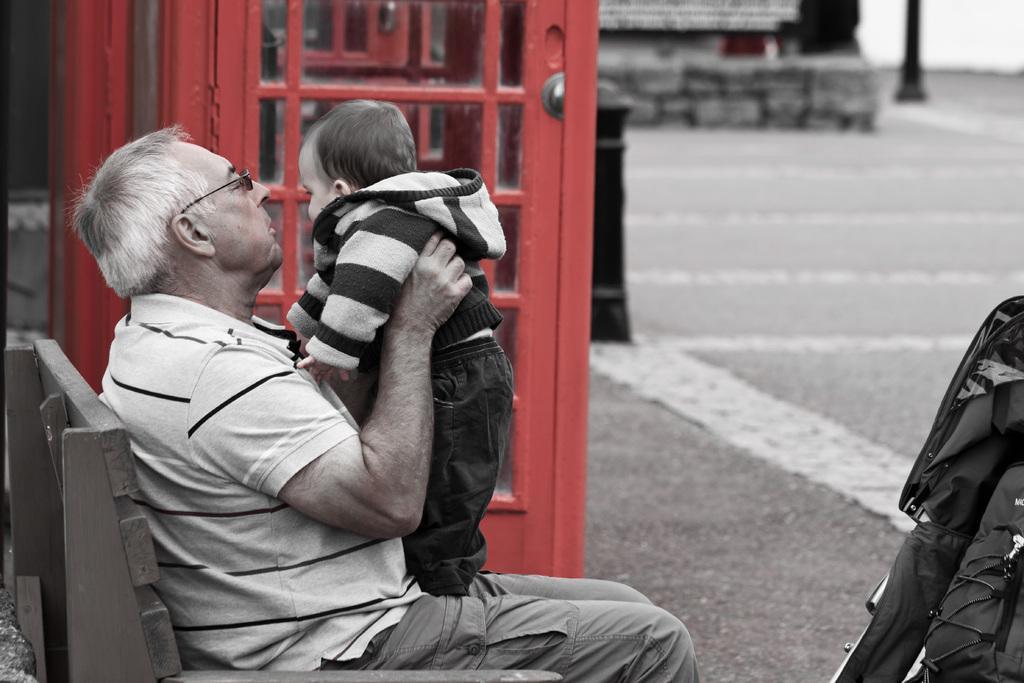Can you describe this image briefly? This image is taken outdoors. On the left side of the image a man is sitting on the bench and he is holding a baby in his hands. On the right side of the image there is a baby carrier. In the background there is a floor. There is a pole and there is a cabin. 